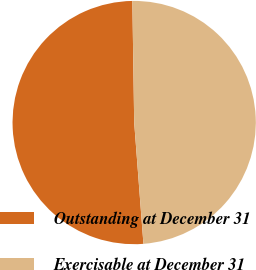Convert chart to OTSL. <chart><loc_0><loc_0><loc_500><loc_500><pie_chart><fcel>Outstanding at December 31<fcel>Exercisable at December 31<nl><fcel>50.97%<fcel>49.03%<nl></chart> 